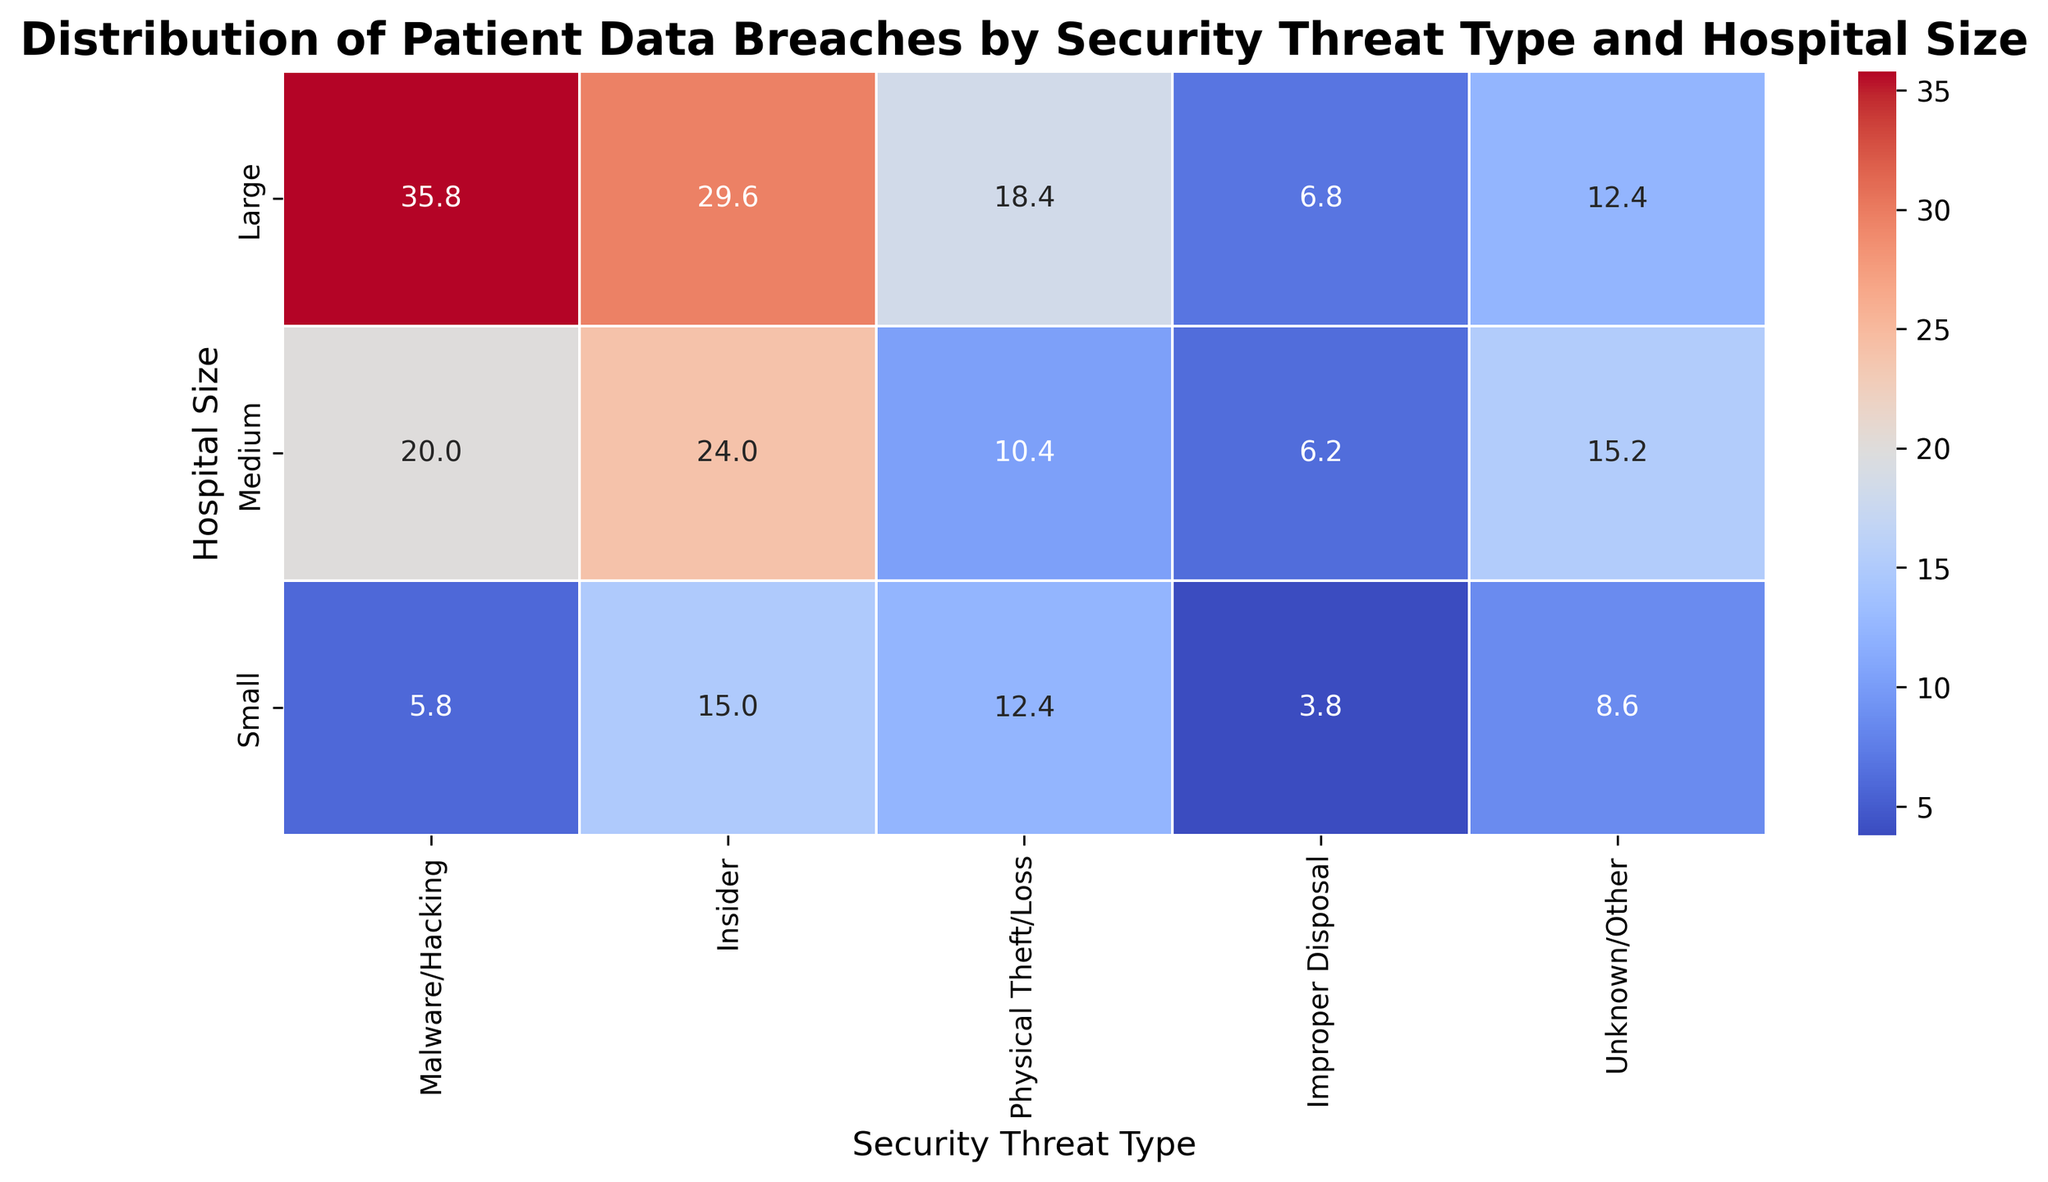What is the average number of breaches for Large hospitals across all threat types? Look at the row corresponding to Large hospitals, which lists the average breaches for each threat type: 35.8, 29.6, 18.4, 6.8, and 12.4. Sum these values and divide by the number of threat types (5): (35.8 + 29.6 + 18.4 + 6.8 + 12.4) / 5 = 103 / 5
Answer: 20.6 Which hospital size has the highest average number of Physical Theft/Loss breaches? Check the Physical Theft/Loss column. The values are 12.4 (Small), 10.4 (Medium), and 18.4 (Large). The highest value is 18.4, which corresponds to Large hospitals.
Answer: Large Which security threat type has the lowest average number of breaches for Medium hospitals? Look at the row corresponding to Medium hospitals and find the smallest value: 20 (Malware/Hacking), 24 (Insider), 10.4 (Physical Theft/Loss), 6.2 (Improper Disposal), 15.2 (Unknown/Other). The smallest value is 6.2, which corresponds to Improper Disposal.
Answer: Improper Disposal How much greater is the average number of Insider breaches in Large hospitals compared to Small hospitals? The average number of Insider breaches in Large hospitals is 29.6; for Small hospitals, it is 15.0. Subtract the smaller value from the larger value: 29.6 - 15.0 = 14.6
Answer: 14.6 Is the average number of breaches due to Malware/Hacking higher in Medium hospitals than in Small hospitals? If yes, by how much? The average number of breaches due to Malware/Hacking in Medium hospitals is 20.0, and in Small hospitals, it is 5.8. Since 20.0 is greater than 5.8, subtract the smaller value from the larger value: 20.0 - 5.8 = 14.2
Answer: Yes, by 14.2 For which hospital size is the variation in breach counts across different threat types the largest? Calculate the range (max value - min value) for each hospital size. Small: max 15 - min 5.8 = 9.2, Medium: max 24 - min 6.2 = 17.8, Large: max 35.8 - min 6.8 = 29. Check which range value is the largest.
Answer: Large What is the total number of breaches for Small hospitals for all threat types? Find the average number of breaches for Small hospitals: 5.8, 15.0, 12.4, 3.8, 8.6. Sum these values: 5.8 + 15.0 + 12.4 + 3.8 + 8.6 = 45.6
Answer: 45.6 